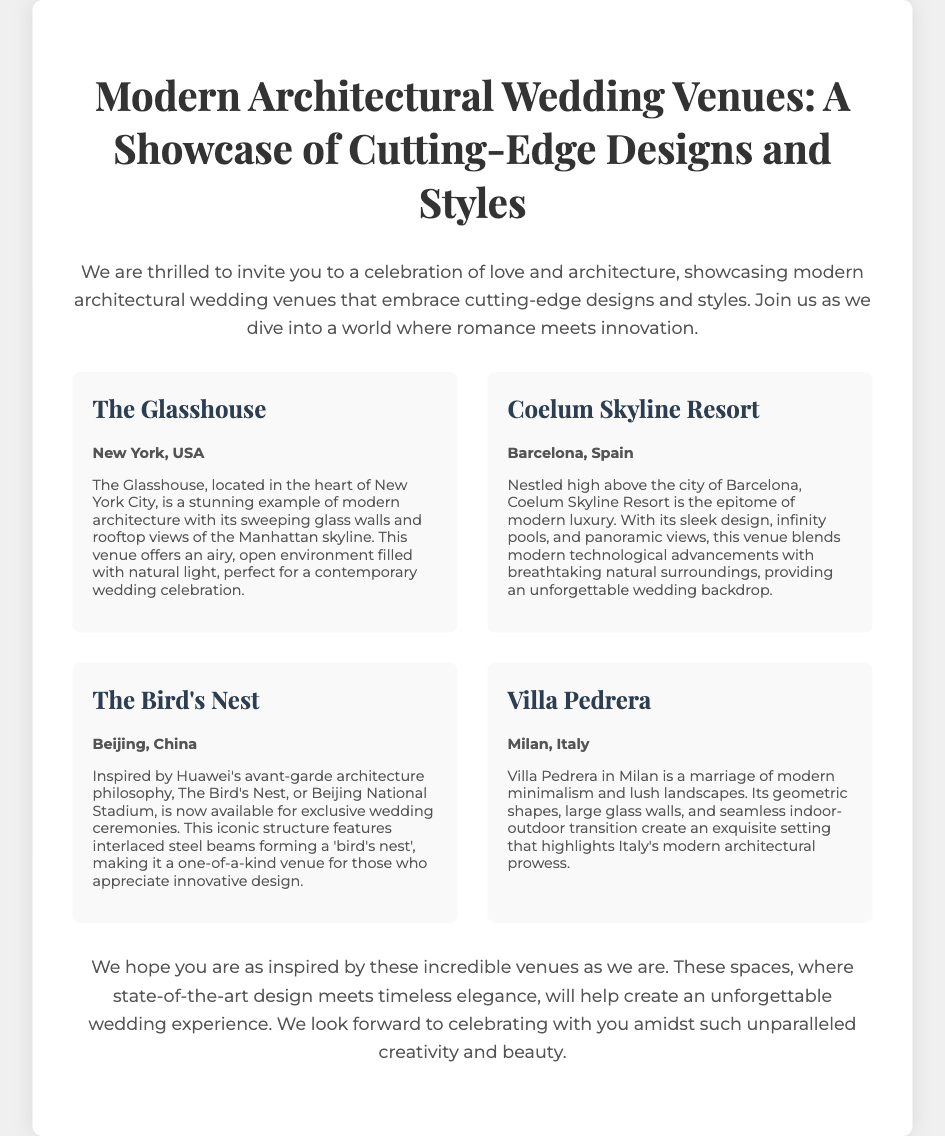What is the title of the showcase? The title is displayed prominently at the top of the document, indicating the focus of the invitation.
Answer: Modern Architectural Wedding Venues: A Showcase of Cutting-Edge Designs and Styles Where is The Glasshouse located? The location of each venue is specified under the venue names, which helps to identify where the events will take place.
Answer: New York, USA What type of architecture does Villa Pedrera represent? The description provides insight into the architectural style of Villa Pedrera, emphasizing its characteristics.
Answer: Modern minimalism How many venues are showcased in the document? The number of venues can be counted based on the sections in the document dedicated to each venue, indicating the breadth of the showcase.
Answer: Four What unique feature does Coelum Skyline Resort offer? The description highlights the standout elements that make this venue special, helping to understand its appeal.
Answer: Infinity pools What architectural philosophy inspired The Bird's Nest? The venue's description references the specific architectural approach that influenced its design, adding depth to its significance.
Answer: Avant-garde architecture What common theme is mentioned in the closing paragraph? The closing remarks often summarize the overarching message of the invitation, providing insight into the event’s purpose.
Answer: Unforgettable wedding experience What is the main purpose of the invitation? The introduction clarifies the reason for the invitation, outlining what attendees can expect.
Answer: To celebrate love and architecture 